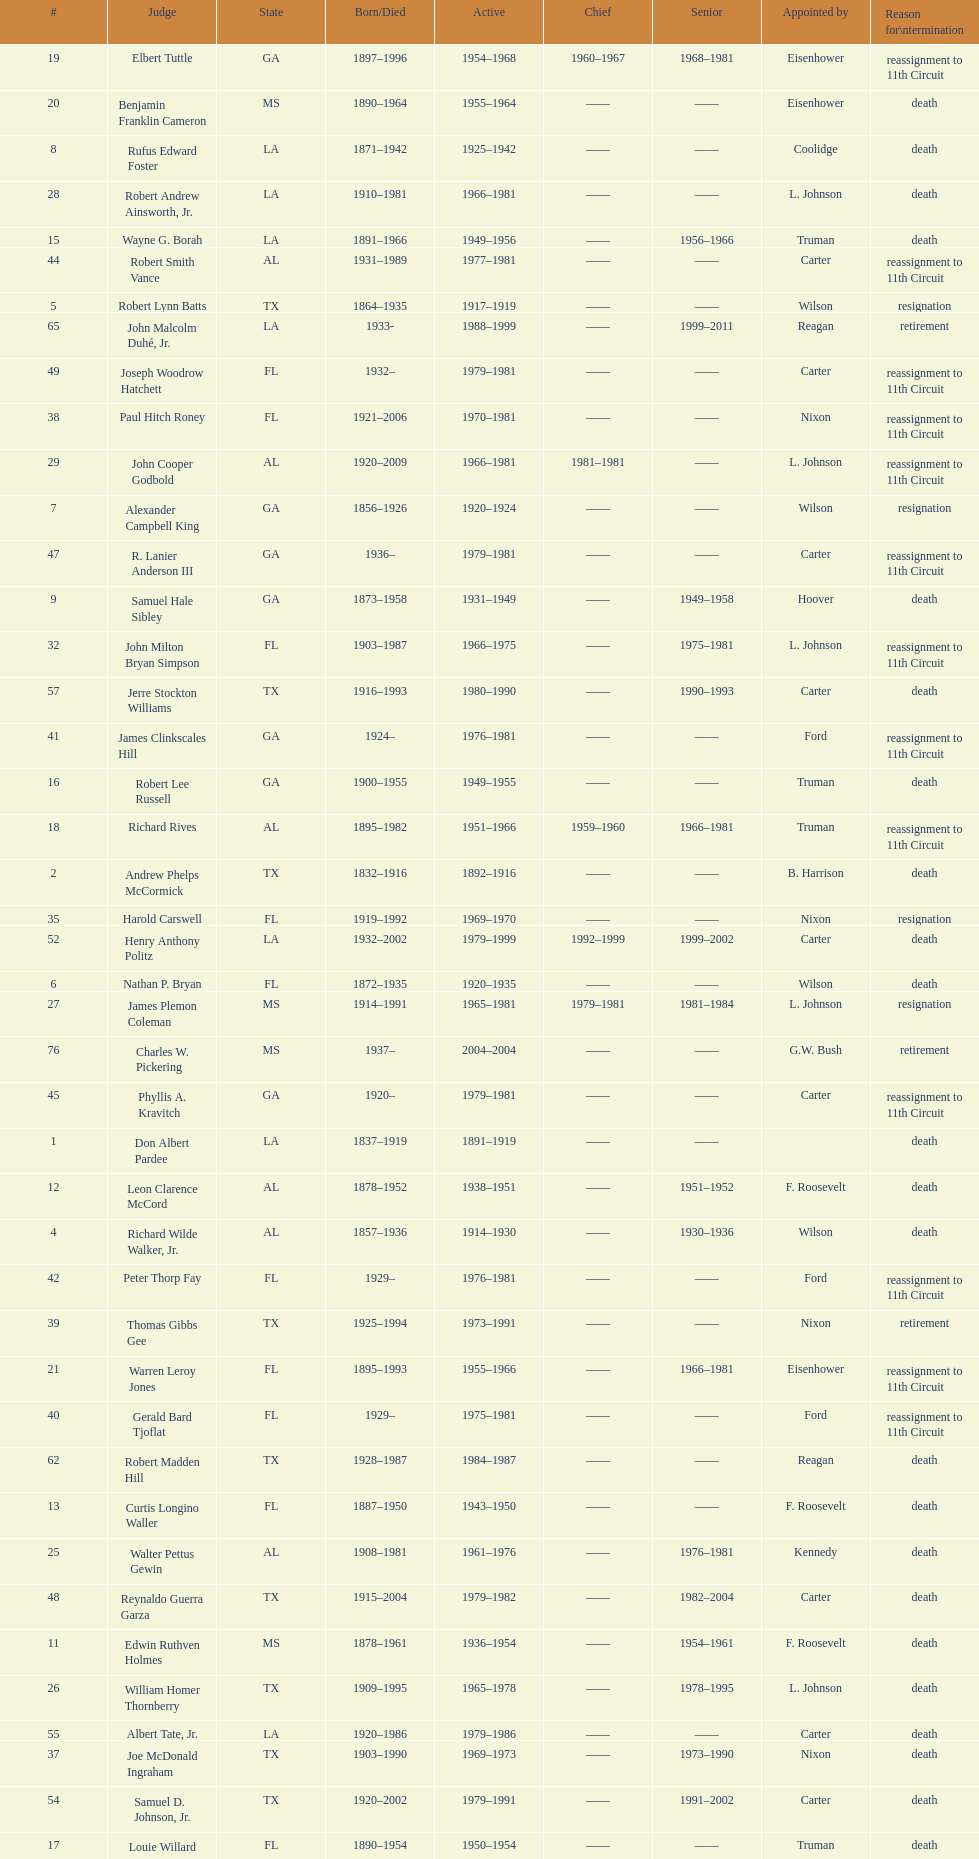Which judge was last appointed by president truman? Richard Rives. 